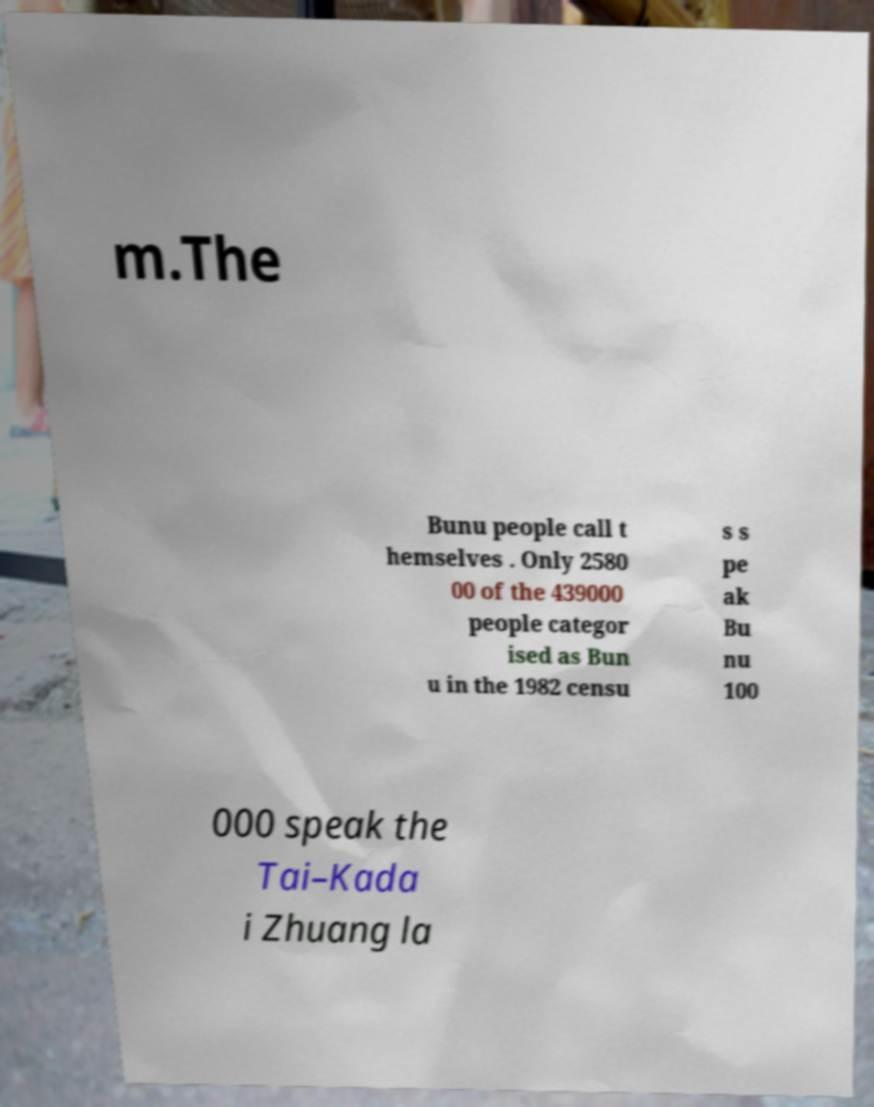Please identify and transcribe the text found in this image. m.The Bunu people call t hemselves . Only 2580 00 of the 439000 people categor ised as Bun u in the 1982 censu s s pe ak Bu nu 100 000 speak the Tai–Kada i Zhuang la 